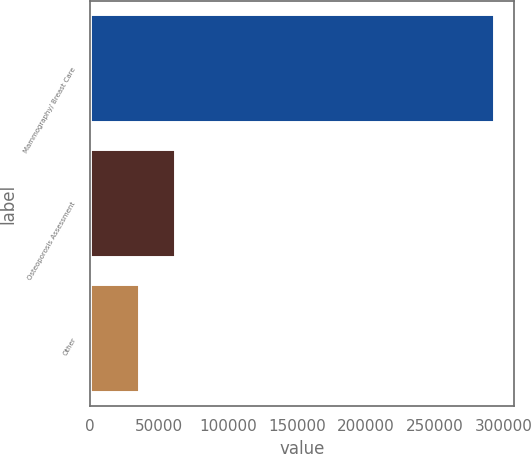<chart> <loc_0><loc_0><loc_500><loc_500><bar_chart><fcel>Mammography/ Breast Care<fcel>Osteoporosis Assessment<fcel>Other<nl><fcel>292773<fcel>61372.2<fcel>35661<nl></chart> 